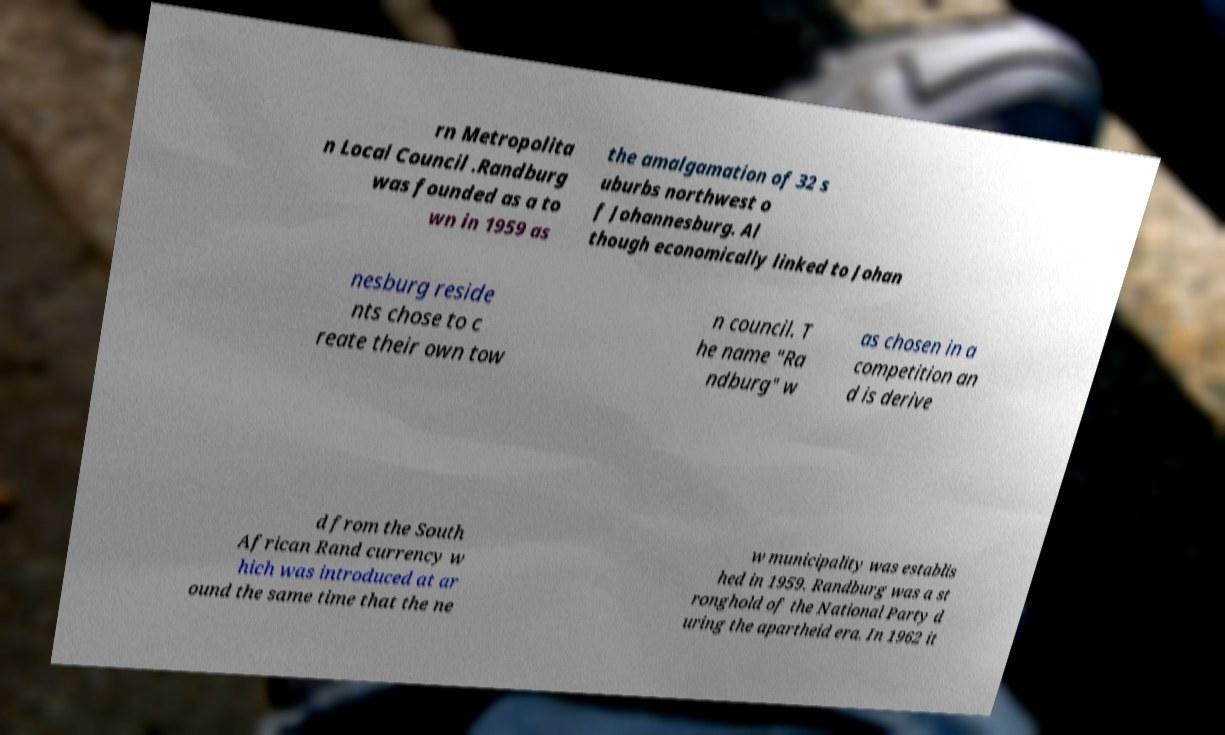Please identify and transcribe the text found in this image. rn Metropolita n Local Council .Randburg was founded as a to wn in 1959 as the amalgamation of 32 s uburbs northwest o f Johannesburg. Al though economically linked to Johan nesburg reside nts chose to c reate their own tow n council. T he name "Ra ndburg" w as chosen in a competition an d is derive d from the South African Rand currency w hich was introduced at ar ound the same time that the ne w municipality was establis hed in 1959. Randburg was a st ronghold of the National Party d uring the apartheid era. In 1962 it 